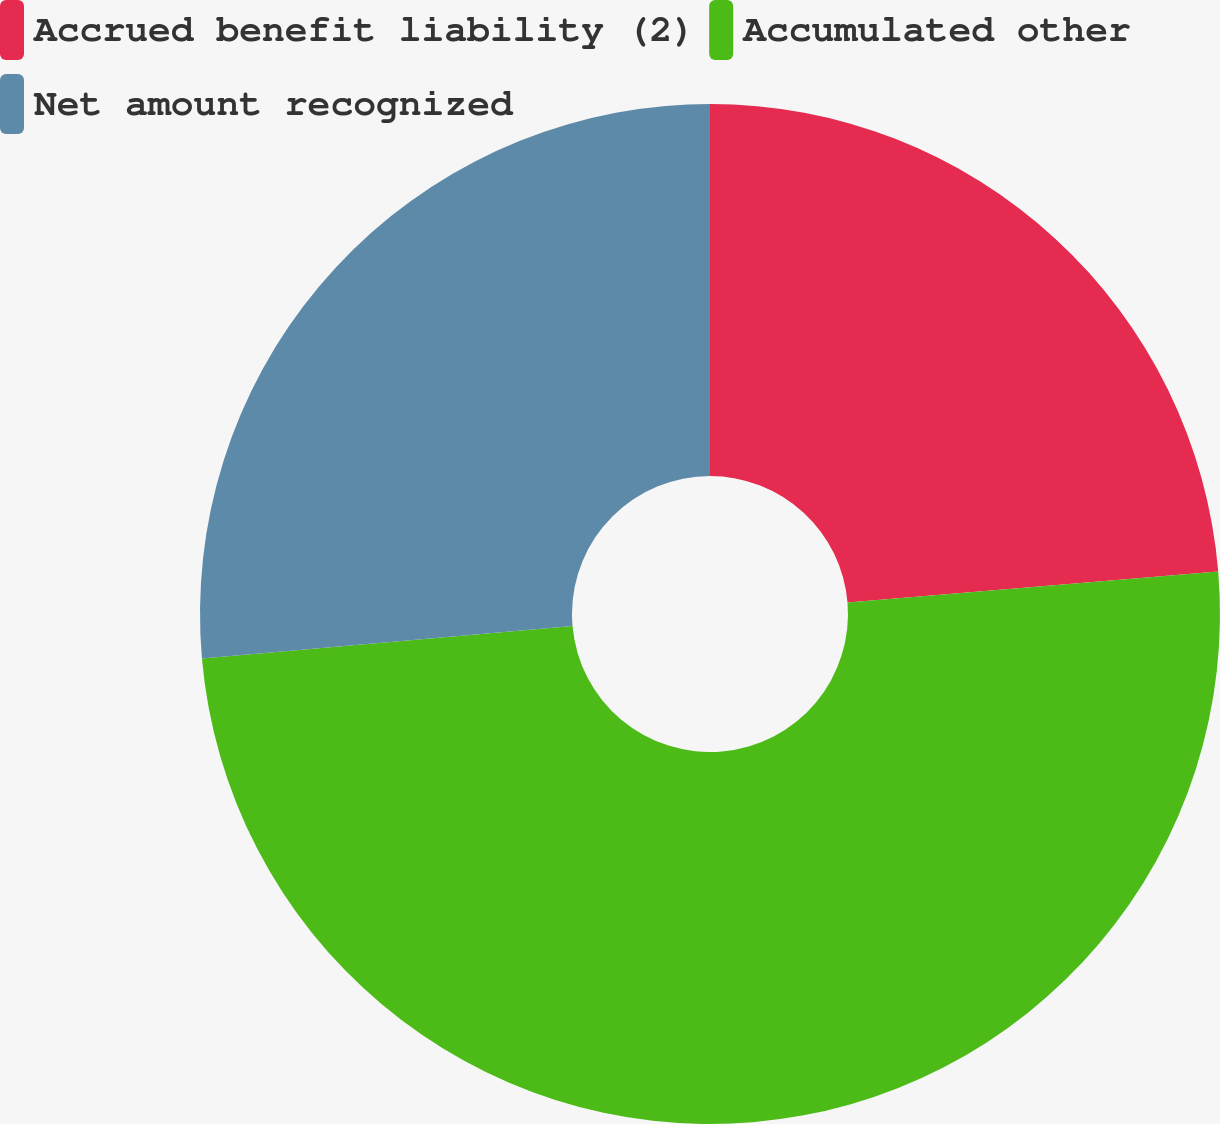<chart> <loc_0><loc_0><loc_500><loc_500><pie_chart><fcel>Accrued benefit liability (2)<fcel>Accumulated other<fcel>Net amount recognized<nl><fcel>23.67%<fcel>49.94%<fcel>26.39%<nl></chart> 